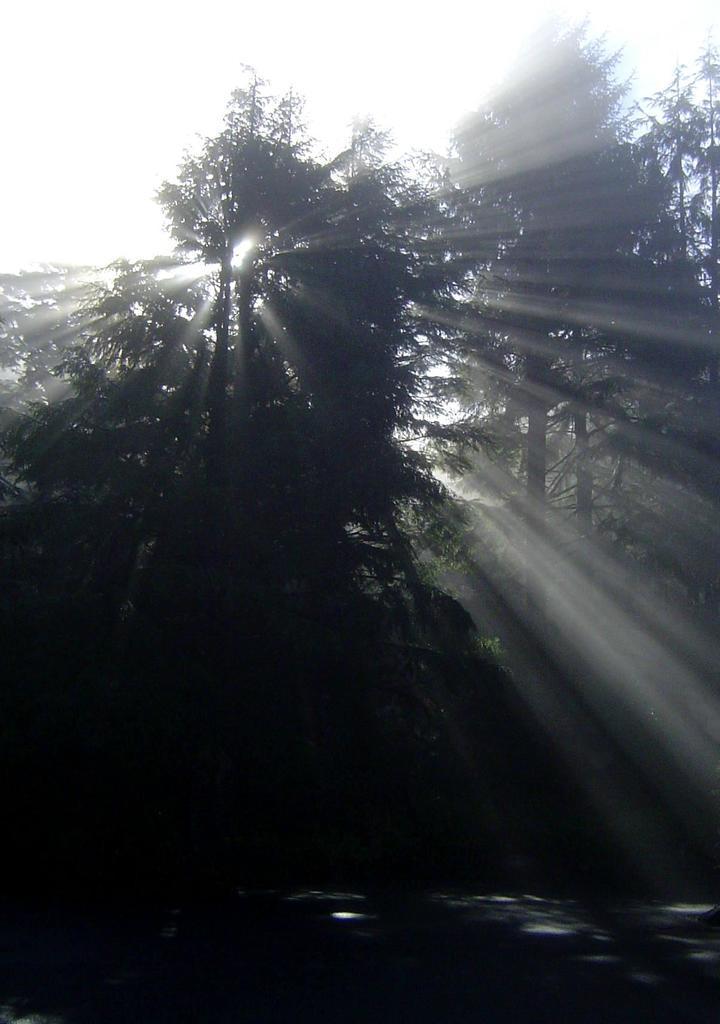Please provide a concise description of this image. In this image we can see few trees and sky in the background. 